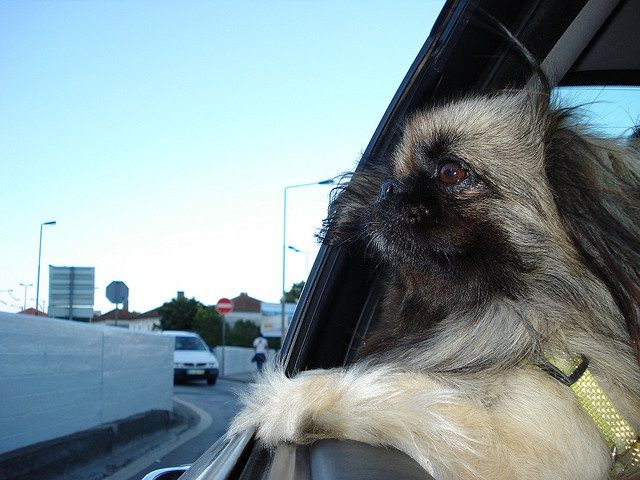Describe the objects in this image and their specific colors. I can see dog in lightblue, black, darkgray, gray, and beige tones, car in lightblue, black, navy, blue, and gray tones, car in lightblue, black, and navy tones, people in lightblue, black, navy, gray, and blue tones, and stop sign in lightblue, gray, and blue tones in this image. 